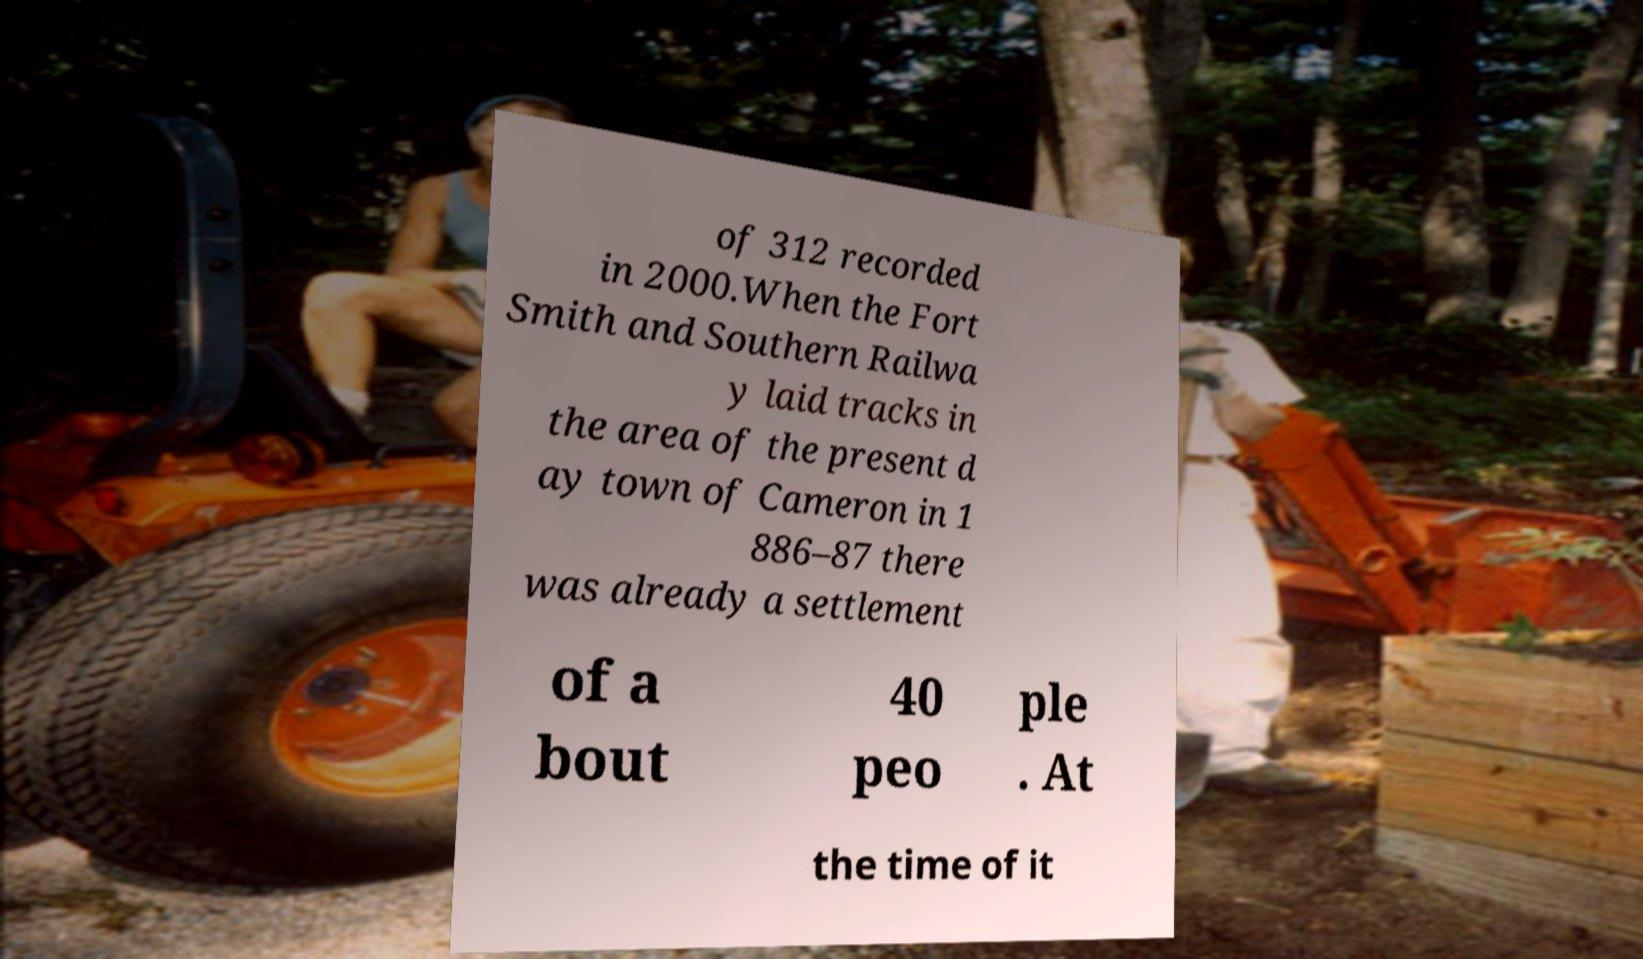There's text embedded in this image that I need extracted. Can you transcribe it verbatim? of 312 recorded in 2000.When the Fort Smith and Southern Railwa y laid tracks in the area of the present d ay town of Cameron in 1 886–87 there was already a settlement of a bout 40 peo ple . At the time of it 